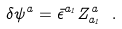Convert formula to latex. <formula><loc_0><loc_0><loc_500><loc_500>\delta \psi ^ { a } = { \bar { \epsilon } } ^ { a _ { 1 } } Z ^ { a } _ { a _ { 1 } } \ .</formula> 